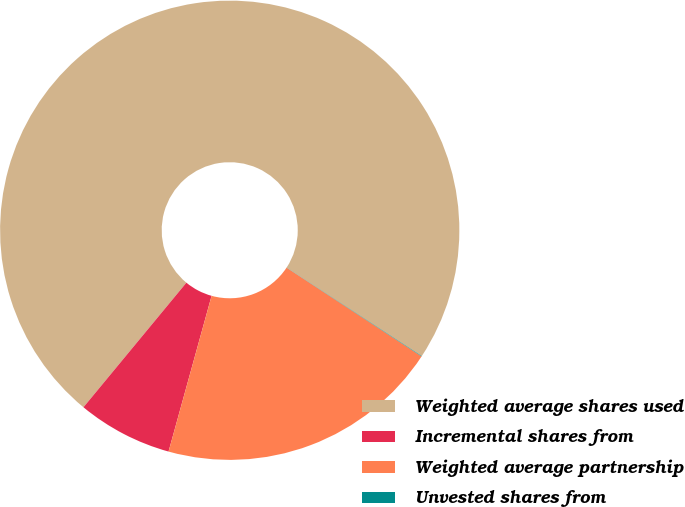<chart> <loc_0><loc_0><loc_500><loc_500><pie_chart><fcel>Weighted average shares used<fcel>Incremental shares from<fcel>Weighted average partnership<fcel>Unvested shares from<nl><fcel>73.24%<fcel>6.7%<fcel>20.03%<fcel>0.03%<nl></chart> 